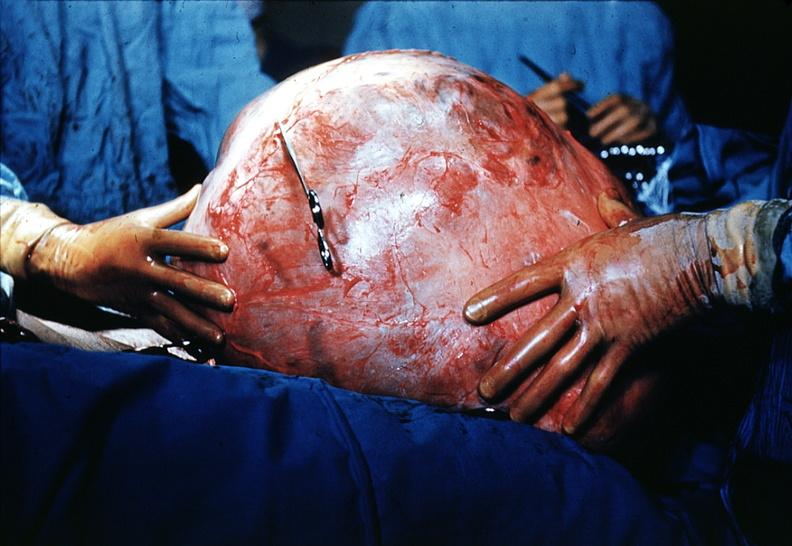what is present?
Answer the question using a single word or phrase. Ovary 